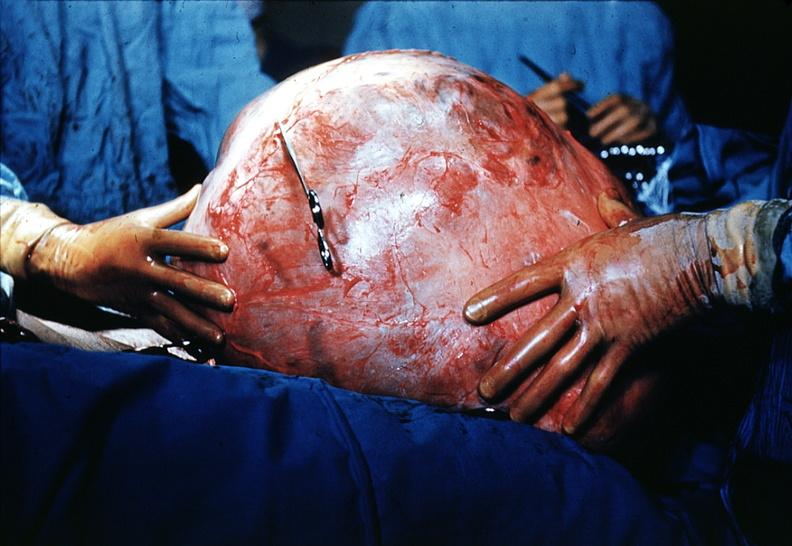what is present?
Answer the question using a single word or phrase. Ovary 